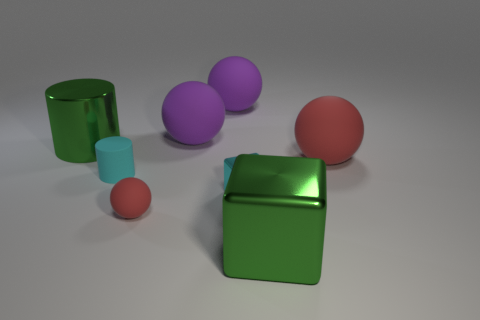Is there anything else of the same color as the large cylinder?
Your answer should be very brief. Yes. There is a big metallic cube; is its color the same as the tiny cylinder that is on the left side of the big red object?
Give a very brief answer. No. Are there fewer small balls that are on the left side of the small cyan matte thing than tiny red matte spheres?
Your answer should be very brief. Yes. There is a green object that is behind the green cube; what is it made of?
Your response must be concise. Metal. How many other objects are the same size as the green metal cylinder?
Give a very brief answer. 4. Is the size of the metallic cylinder the same as the red ball that is right of the small red matte ball?
Your answer should be very brief. Yes. The big green object in front of the big matte sphere in front of the green object that is behind the cyan rubber cylinder is what shape?
Offer a very short reply. Cube. Are there fewer big green cylinders than tiny green spheres?
Your answer should be very brief. No. Are there any green cylinders left of the green metallic cylinder?
Your answer should be compact. No. There is a thing that is to the left of the big red object and right of the cyan metallic thing; what shape is it?
Offer a terse response. Cube. 